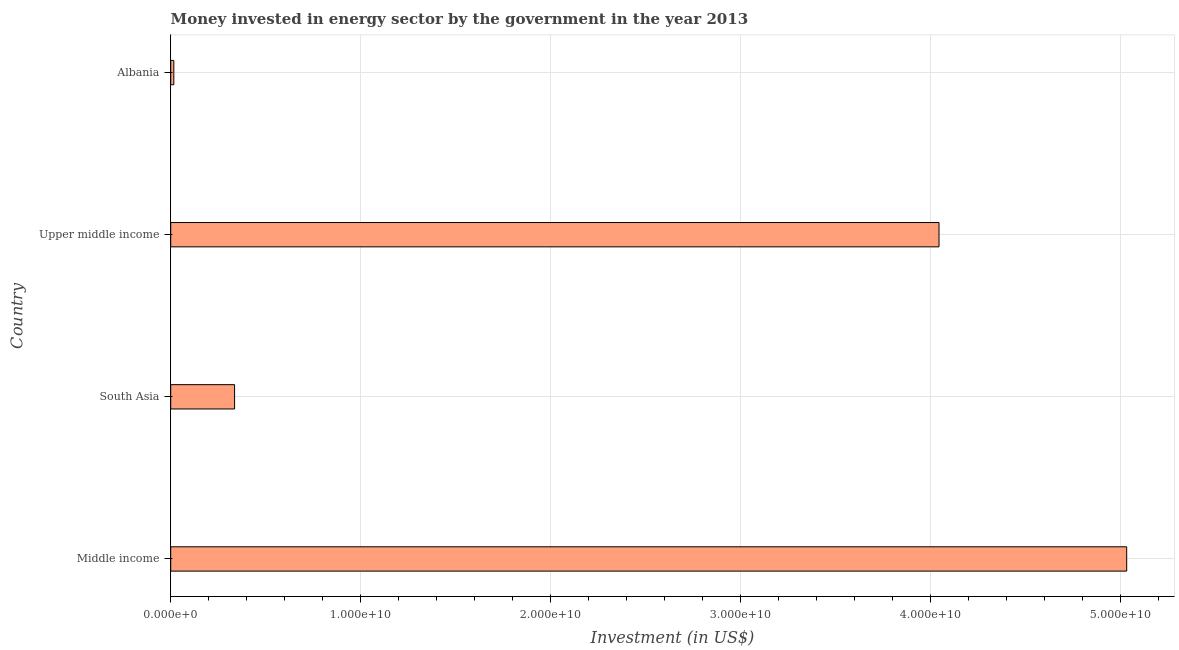Does the graph contain any zero values?
Provide a succinct answer. No. What is the title of the graph?
Your answer should be very brief. Money invested in energy sector by the government in the year 2013. What is the label or title of the X-axis?
Your answer should be compact. Investment (in US$). What is the label or title of the Y-axis?
Give a very brief answer. Country. What is the investment in energy in Middle income?
Your answer should be compact. 5.03e+1. Across all countries, what is the maximum investment in energy?
Provide a short and direct response. 5.03e+1. Across all countries, what is the minimum investment in energy?
Ensure brevity in your answer.  1.64e+08. In which country was the investment in energy maximum?
Offer a terse response. Middle income. In which country was the investment in energy minimum?
Provide a short and direct response. Albania. What is the sum of the investment in energy?
Your response must be concise. 9.43e+1. What is the difference between the investment in energy in Albania and Upper middle income?
Provide a succinct answer. -4.03e+1. What is the average investment in energy per country?
Keep it short and to the point. 2.36e+1. What is the median investment in energy?
Make the answer very short. 2.19e+1. In how many countries, is the investment in energy greater than 24000000000 US$?
Offer a terse response. 2. What is the ratio of the investment in energy in Albania to that in South Asia?
Your answer should be compact. 0.05. What is the difference between the highest and the second highest investment in energy?
Keep it short and to the point. 9.88e+09. What is the difference between the highest and the lowest investment in energy?
Offer a terse response. 5.02e+1. In how many countries, is the investment in energy greater than the average investment in energy taken over all countries?
Your response must be concise. 2. How many bars are there?
Keep it short and to the point. 4. Are all the bars in the graph horizontal?
Offer a terse response. Yes. How many countries are there in the graph?
Provide a short and direct response. 4. Are the values on the major ticks of X-axis written in scientific E-notation?
Offer a very short reply. Yes. What is the Investment (in US$) of Middle income?
Provide a short and direct response. 5.03e+1. What is the Investment (in US$) in South Asia?
Ensure brevity in your answer.  3.36e+09. What is the Investment (in US$) of Upper middle income?
Keep it short and to the point. 4.04e+1. What is the Investment (in US$) of Albania?
Keep it short and to the point. 1.64e+08. What is the difference between the Investment (in US$) in Middle income and South Asia?
Ensure brevity in your answer.  4.70e+1. What is the difference between the Investment (in US$) in Middle income and Upper middle income?
Provide a succinct answer. 9.88e+09. What is the difference between the Investment (in US$) in Middle income and Albania?
Your response must be concise. 5.02e+1. What is the difference between the Investment (in US$) in South Asia and Upper middle income?
Give a very brief answer. -3.71e+1. What is the difference between the Investment (in US$) in South Asia and Albania?
Your answer should be very brief. 3.20e+09. What is the difference between the Investment (in US$) in Upper middle income and Albania?
Your answer should be very brief. 4.03e+1. What is the ratio of the Investment (in US$) in Middle income to that in South Asia?
Provide a short and direct response. 14.97. What is the ratio of the Investment (in US$) in Middle income to that in Upper middle income?
Provide a succinct answer. 1.24. What is the ratio of the Investment (in US$) in Middle income to that in Albania?
Provide a short and direct response. 306.84. What is the ratio of the Investment (in US$) in South Asia to that in Upper middle income?
Give a very brief answer. 0.08. What is the ratio of the Investment (in US$) in South Asia to that in Albania?
Your answer should be compact. 20.5. What is the ratio of the Investment (in US$) in Upper middle income to that in Albania?
Your response must be concise. 246.6. 